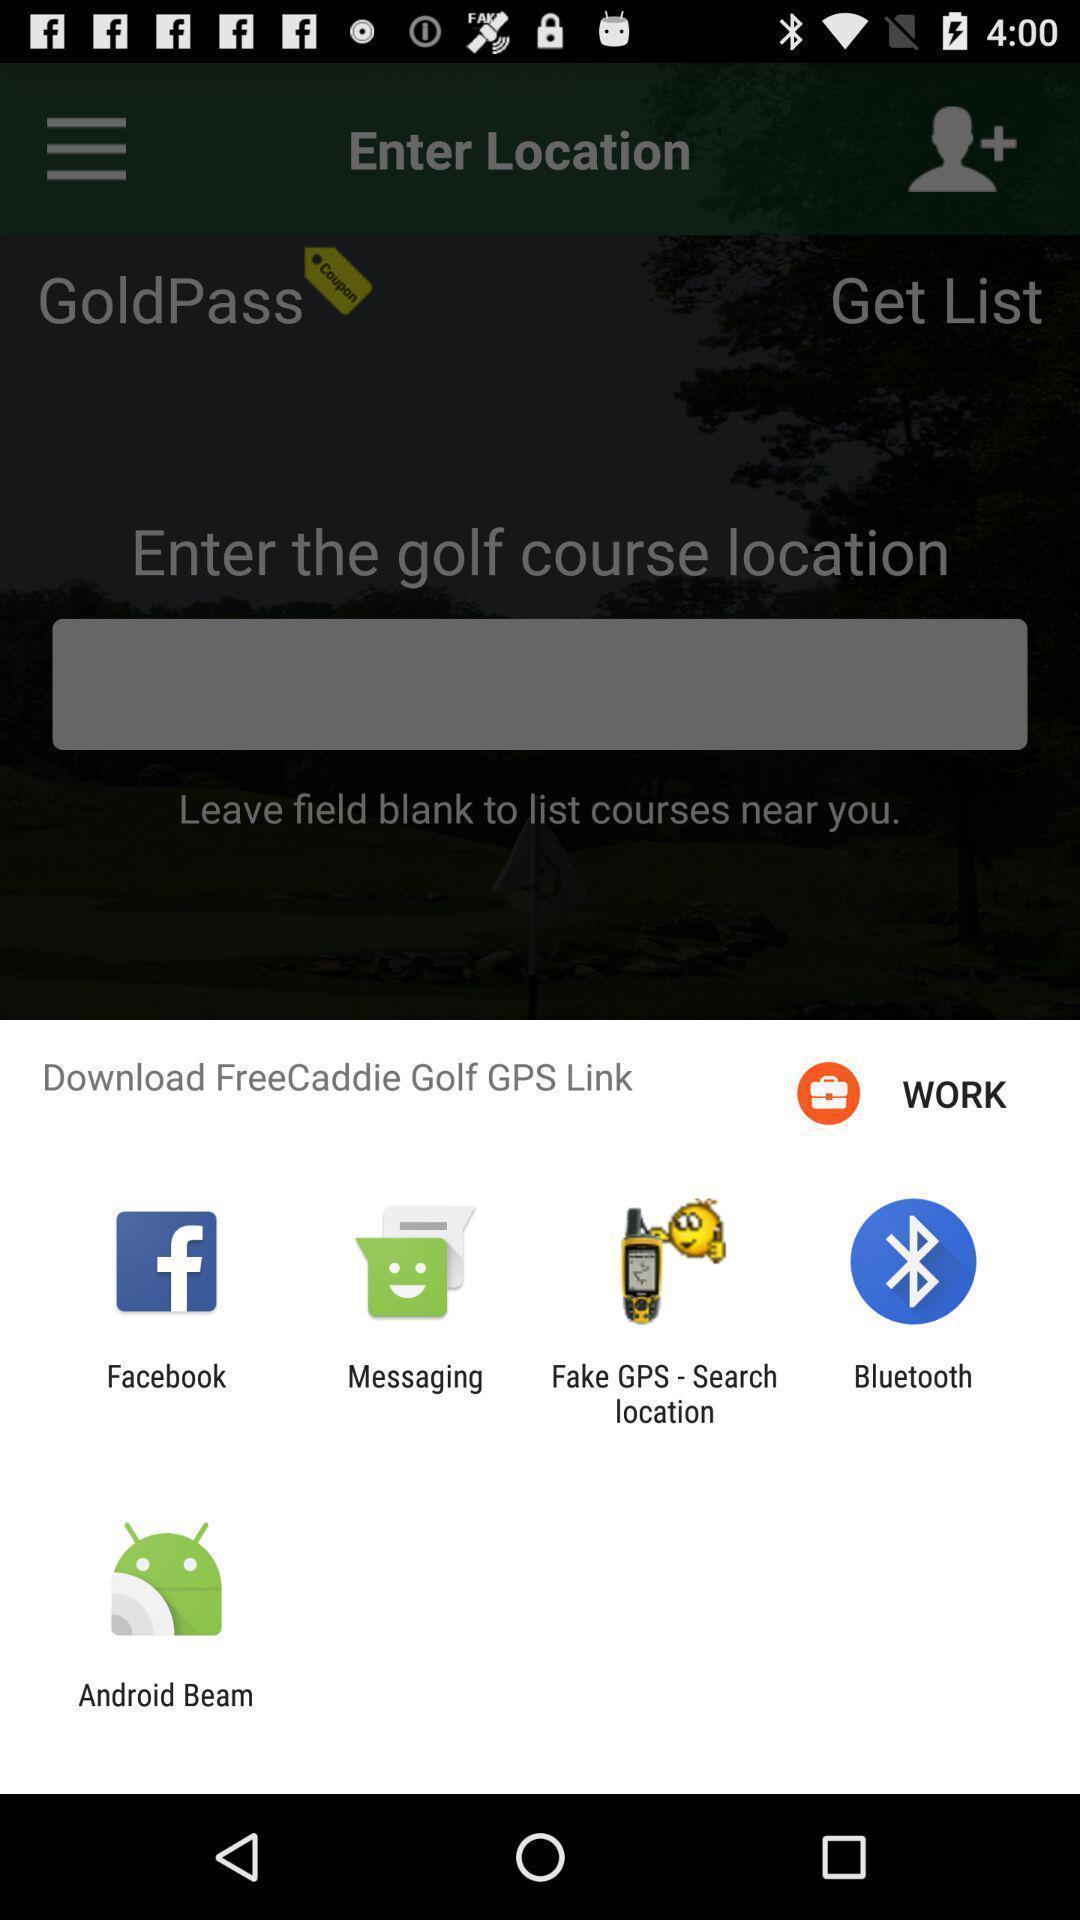Provide a textual representation of this image. Popup page for downloading through different apps. 